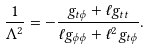<formula> <loc_0><loc_0><loc_500><loc_500>\frac { 1 } { \Lambda ^ { 2 } } = - \frac { g _ { t \phi } + \ell g _ { t t } } { \ell g _ { \phi \phi } + \ell ^ { 2 } g _ { t \phi } } .</formula> 